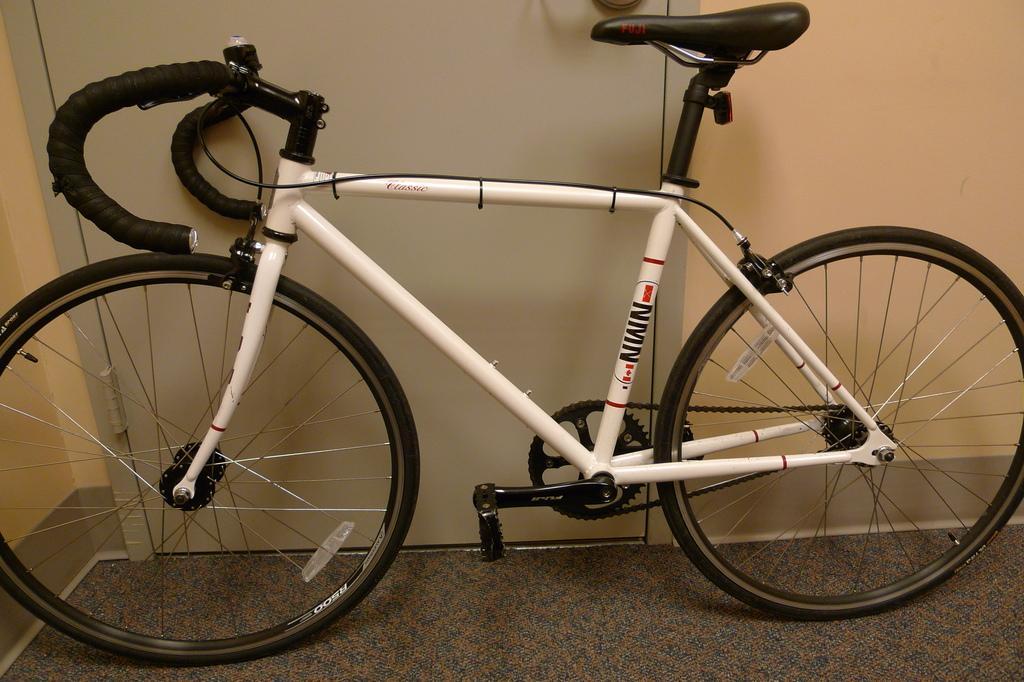Describe this image in one or two sentences. In this picture, we see the bicycle. It is in white color. At the bottom, we see the carpet or the floor. In the background, we see a grey door and beside that, we see a wall in cream color. 